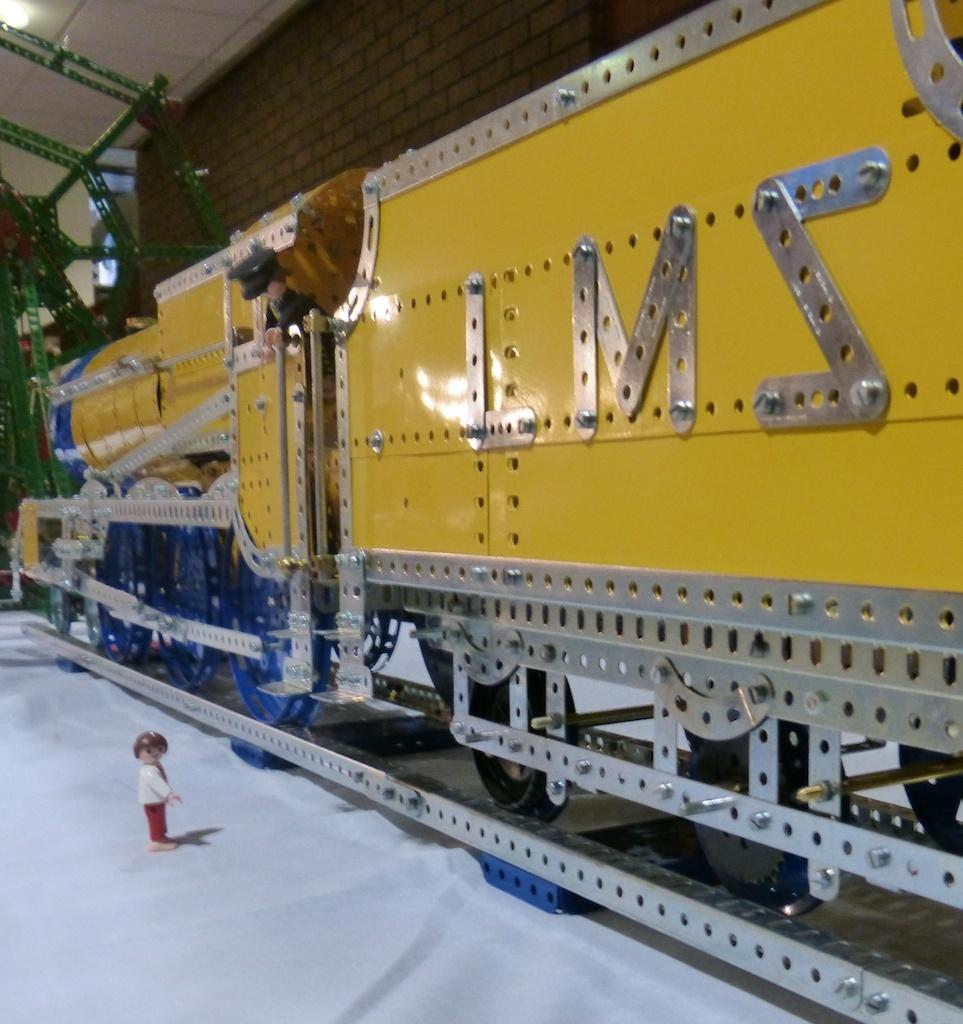Provide a one-sentence caption for the provided image. A model train with the letters LMS on the side. 